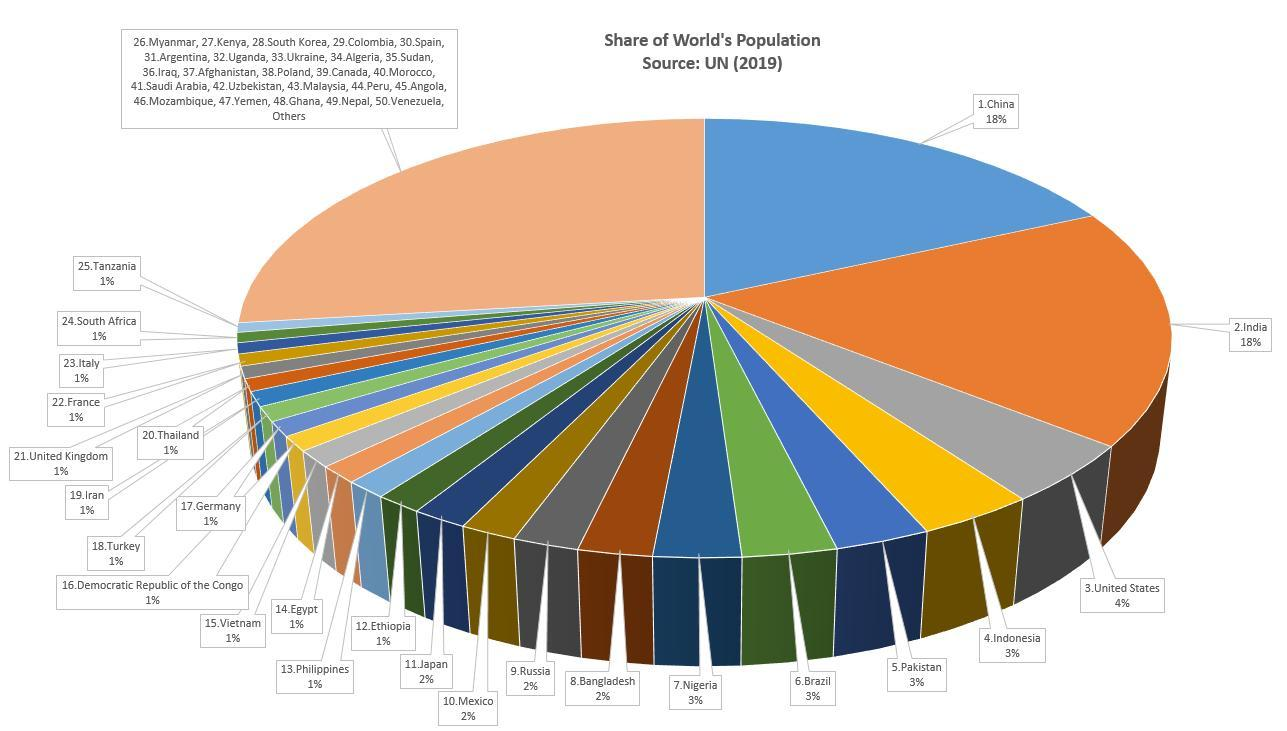Which two countries share the highest population percentage in the world ?
Answer the question with a short phrase. China, India How many countries have 1% of the world's population ? 14 How many countries have 2% of the world's population? 4 What is the gap in the population percentage of India and US ? 14% How many nations contribute to the rest of the share of world population in 'Others' category? 170 How many countries have 3% of the world's population? 4 